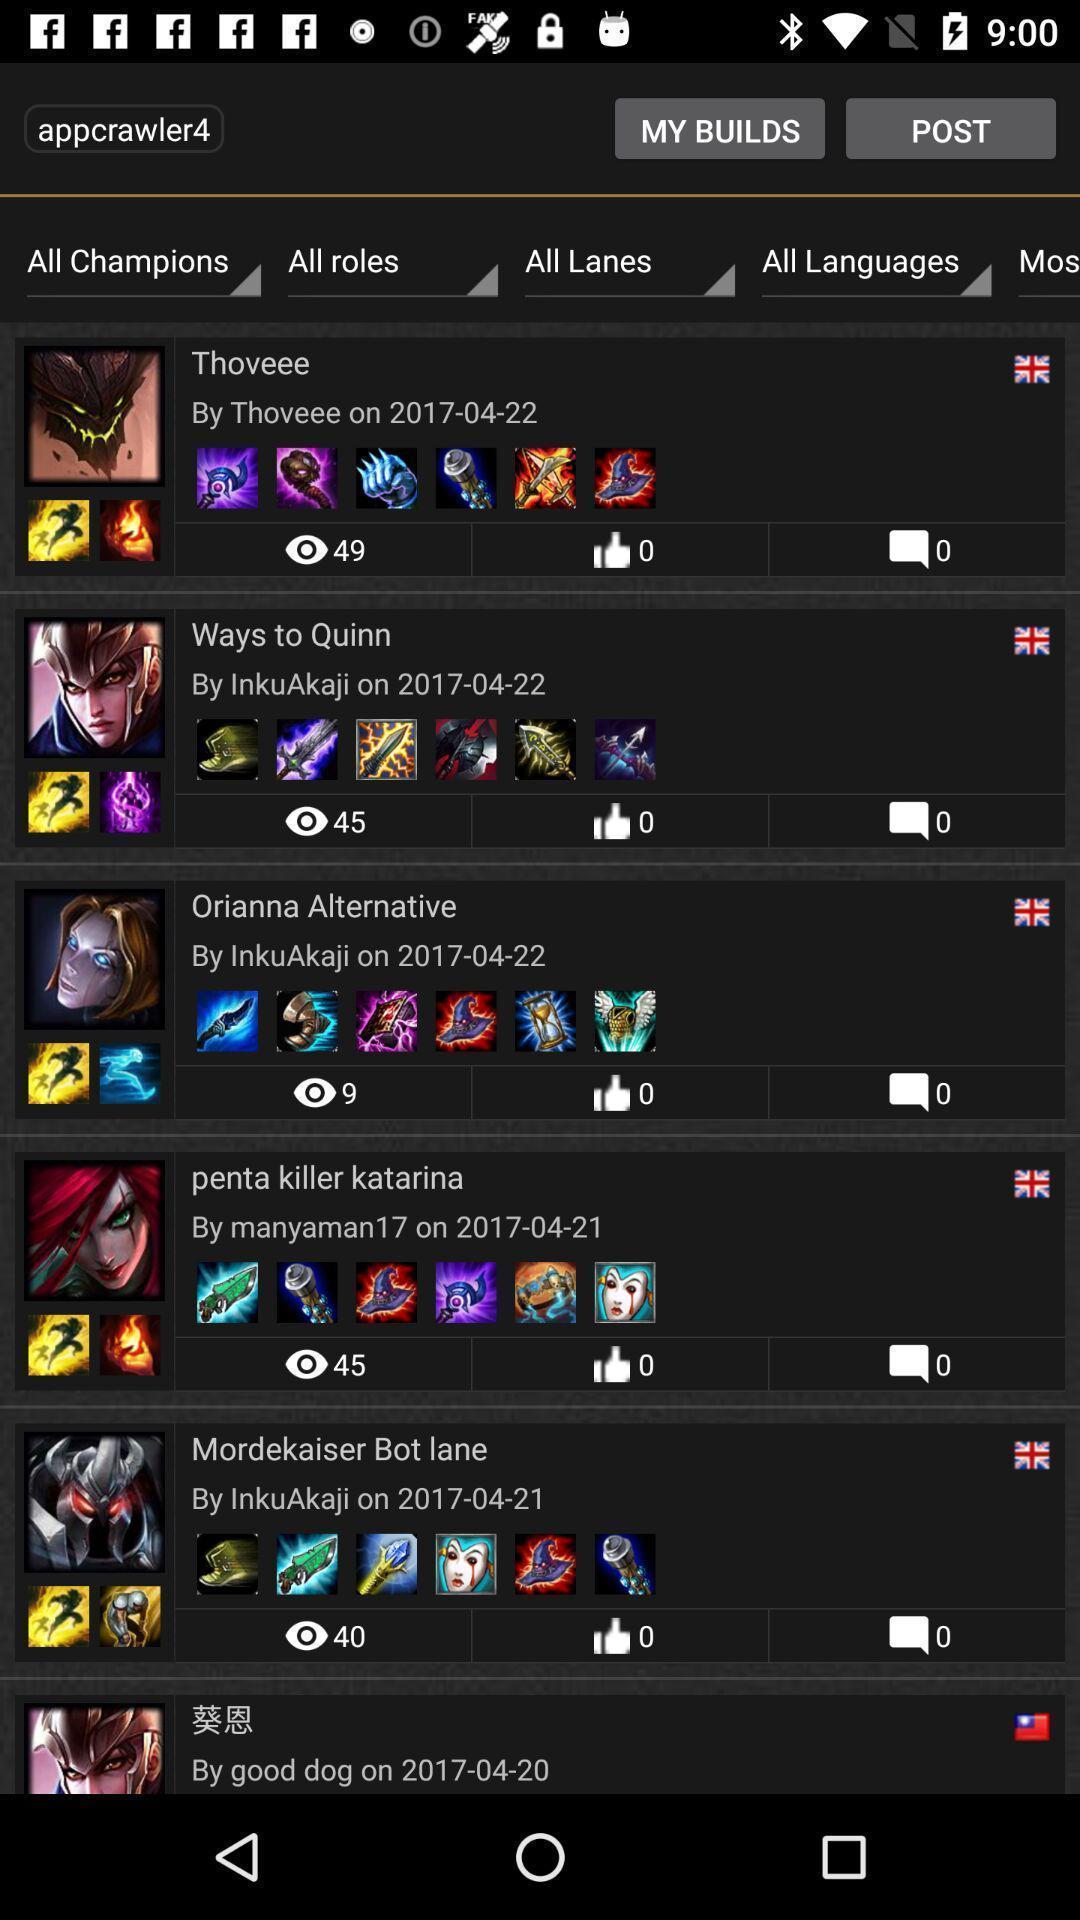Tell me what you see in this picture. Screen displaying different comments on a social app. 